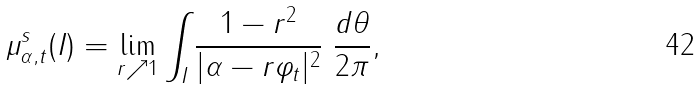Convert formula to latex. <formula><loc_0><loc_0><loc_500><loc_500>\mu ^ { s } _ { \alpha , t } ( I ) = \lim _ { r \nearrow 1 } \int _ { I } \frac { 1 - r ^ { 2 } } { | \alpha - r \varphi _ { t } | ^ { 2 } } \ \frac { d \theta } { 2 \pi } ,</formula> 